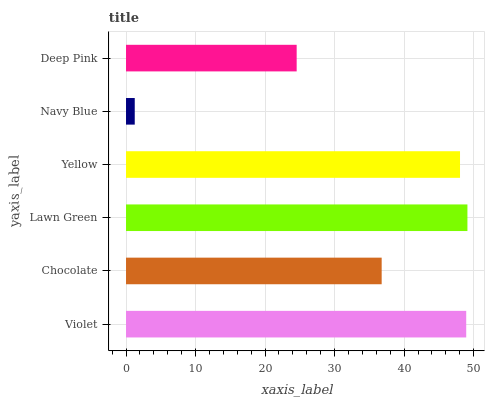Is Navy Blue the minimum?
Answer yes or no. Yes. Is Lawn Green the maximum?
Answer yes or no. Yes. Is Chocolate the minimum?
Answer yes or no. No. Is Chocolate the maximum?
Answer yes or no. No. Is Violet greater than Chocolate?
Answer yes or no. Yes. Is Chocolate less than Violet?
Answer yes or no. Yes. Is Chocolate greater than Violet?
Answer yes or no. No. Is Violet less than Chocolate?
Answer yes or no. No. Is Yellow the high median?
Answer yes or no. Yes. Is Chocolate the low median?
Answer yes or no. Yes. Is Lawn Green the high median?
Answer yes or no. No. Is Yellow the low median?
Answer yes or no. No. 